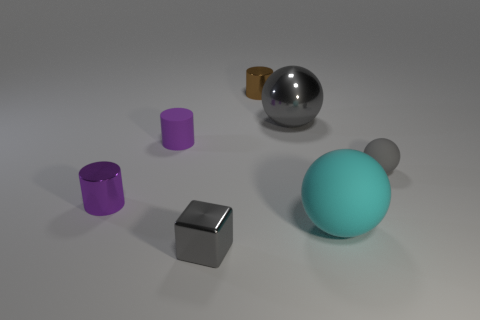There is a big thing right of the gray shiny object that is on the right side of the tiny metallic cylinder behind the small purple metal cylinder; what color is it?
Your response must be concise. Cyan. How many objects are either large red cylinders or large things?
Ensure brevity in your answer.  2. What number of other things are the same shape as the big shiny object?
Make the answer very short. 2. Does the brown cylinder have the same material as the tiny gray object behind the small gray shiny thing?
Keep it short and to the point. No. There is a brown cylinder that is made of the same material as the tiny gray block; what is its size?
Your answer should be compact. Small. What is the size of the gray object that is right of the big shiny sphere?
Offer a terse response. Small. What number of other rubber cylinders have the same size as the purple matte cylinder?
Ensure brevity in your answer.  0. What is the size of the metal object that is the same color as the block?
Ensure brevity in your answer.  Large. Is there a tiny rubber sphere that has the same color as the cube?
Ensure brevity in your answer.  Yes. What is the color of the matte ball that is the same size as the cube?
Your answer should be very brief. Gray. 